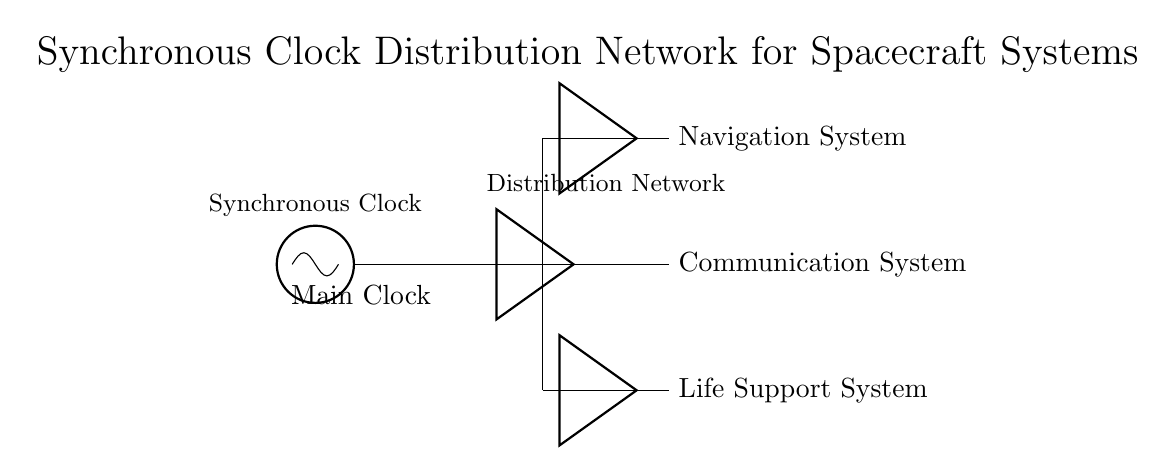What is the main source of the clock signal? The main source is labeled as "Main Clock" in the circuit, which is identified as an oscillator indicating that it generates the clock signal.
Answer: Main Clock How many systems are connected to the clock distribution network? The diagram shows three systems: Navigation System, Communication System, and Life Support System, all connected to the clock distribution network.
Answer: Three systems What type of component is used to buffer the clock signals? The clock signals are buffered using "Buffer" components placed at specific points in the distribution network to enhance signal quality.
Answer: Buffer Which system is connected to the upper branch of the distribution network? The upper branch of the distribution network leads specifically to the Navigation System, as indicated in the diagram.
Answer: Navigation System What function does the distribution network serve in the circuit? The distribution network serves to distribute the clock signal from the Main Clock to various spacecraft systems, ensuring synchronization between them.
Answer: Distribution How does the clock distribution network maintain synchronization across systems? The synchronization is maintained by distributing a single clock signal from the Main Clock through buffering to multiple spacecraft systems ensuring they operate in unison.
Answer: By distributing a single clock signal 